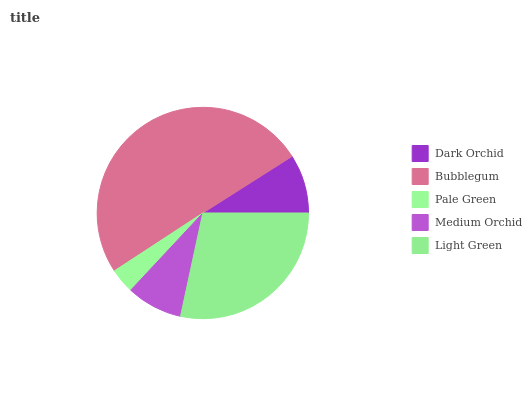Is Pale Green the minimum?
Answer yes or no. Yes. Is Bubblegum the maximum?
Answer yes or no. Yes. Is Bubblegum the minimum?
Answer yes or no. No. Is Pale Green the maximum?
Answer yes or no. No. Is Bubblegum greater than Pale Green?
Answer yes or no. Yes. Is Pale Green less than Bubblegum?
Answer yes or no. Yes. Is Pale Green greater than Bubblegum?
Answer yes or no. No. Is Bubblegum less than Pale Green?
Answer yes or no. No. Is Dark Orchid the high median?
Answer yes or no. Yes. Is Dark Orchid the low median?
Answer yes or no. Yes. Is Medium Orchid the high median?
Answer yes or no. No. Is Medium Orchid the low median?
Answer yes or no. No. 